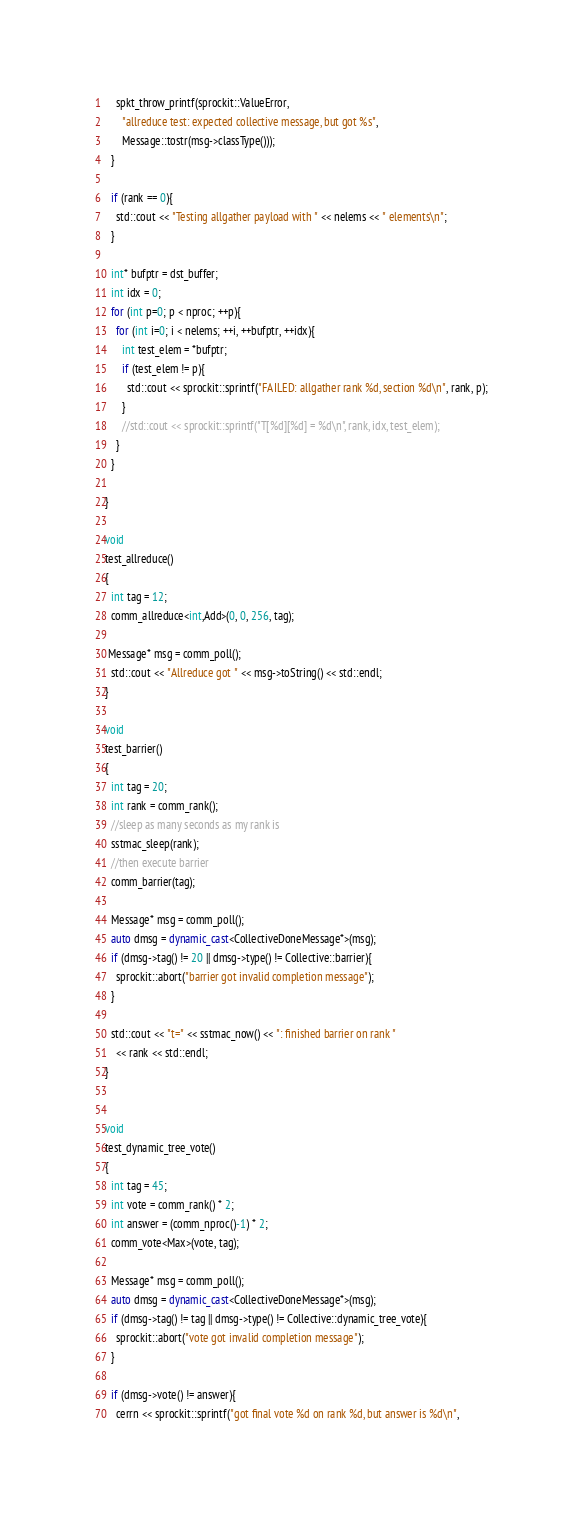Convert code to text. <code><loc_0><loc_0><loc_500><loc_500><_C++_>    spkt_throw_printf(sprockit::ValueError,
      "allreduce test: expected collective message, but got %s",
      Message::tostr(msg->classType()));
  }

  if (rank == 0){
    std::cout << "Testing allgather payload with " << nelems << " elements\n";
  }

  int* bufptr = dst_buffer;
  int idx = 0;
  for (int p=0; p < nproc; ++p){
    for (int i=0; i < nelems; ++i, ++bufptr, ++idx){
      int test_elem = *bufptr;
      if (test_elem != p){
        std::cout << sprockit::sprintf("FAILED: allgather rank %d, section %d\n", rank, p);
      }
      //std::cout << sprockit::sprintf("T[%d][%d] = %d\n", rank, idx, test_elem);
    }
  }

}

void
test_allreduce()
{
  int tag = 12;
  comm_allreduce<int,Add>(0, 0, 256, tag);

 Message* msg = comm_poll();
  std::cout << "Allreduce got " << msg->toString() << std::endl;
}

void
test_barrier()
{
  int tag = 20;
  int rank = comm_rank();
  //sleep as many seconds as my rank is
  sstmac_sleep(rank);
  //then execute barrier
  comm_barrier(tag);

  Message* msg = comm_poll();
  auto dmsg = dynamic_cast<CollectiveDoneMessage*>(msg);
  if (dmsg->tag() != 20 || dmsg->type() != Collective::barrier){
    sprockit::abort("barrier got invalid completion message");
  }

  std::cout << "t=" << sstmac_now() << ": finished barrier on rank "
    << rank << std::endl;
}


void
test_dynamic_tree_vote()
{
  int tag = 45;
  int vote = comm_rank() * 2;
  int answer = (comm_nproc()-1) * 2;
  comm_vote<Max>(vote, tag);

  Message* msg = comm_poll();
  auto dmsg = dynamic_cast<CollectiveDoneMessage*>(msg);
  if (dmsg->tag() != tag || dmsg->type() != Collective::dynamic_tree_vote){
    sprockit::abort("vote got invalid completion message");
  }

  if (dmsg->vote() != answer){
    cerrn << sprockit::sprintf("got final vote %d on rank %d, but answer is %d\n",</code> 